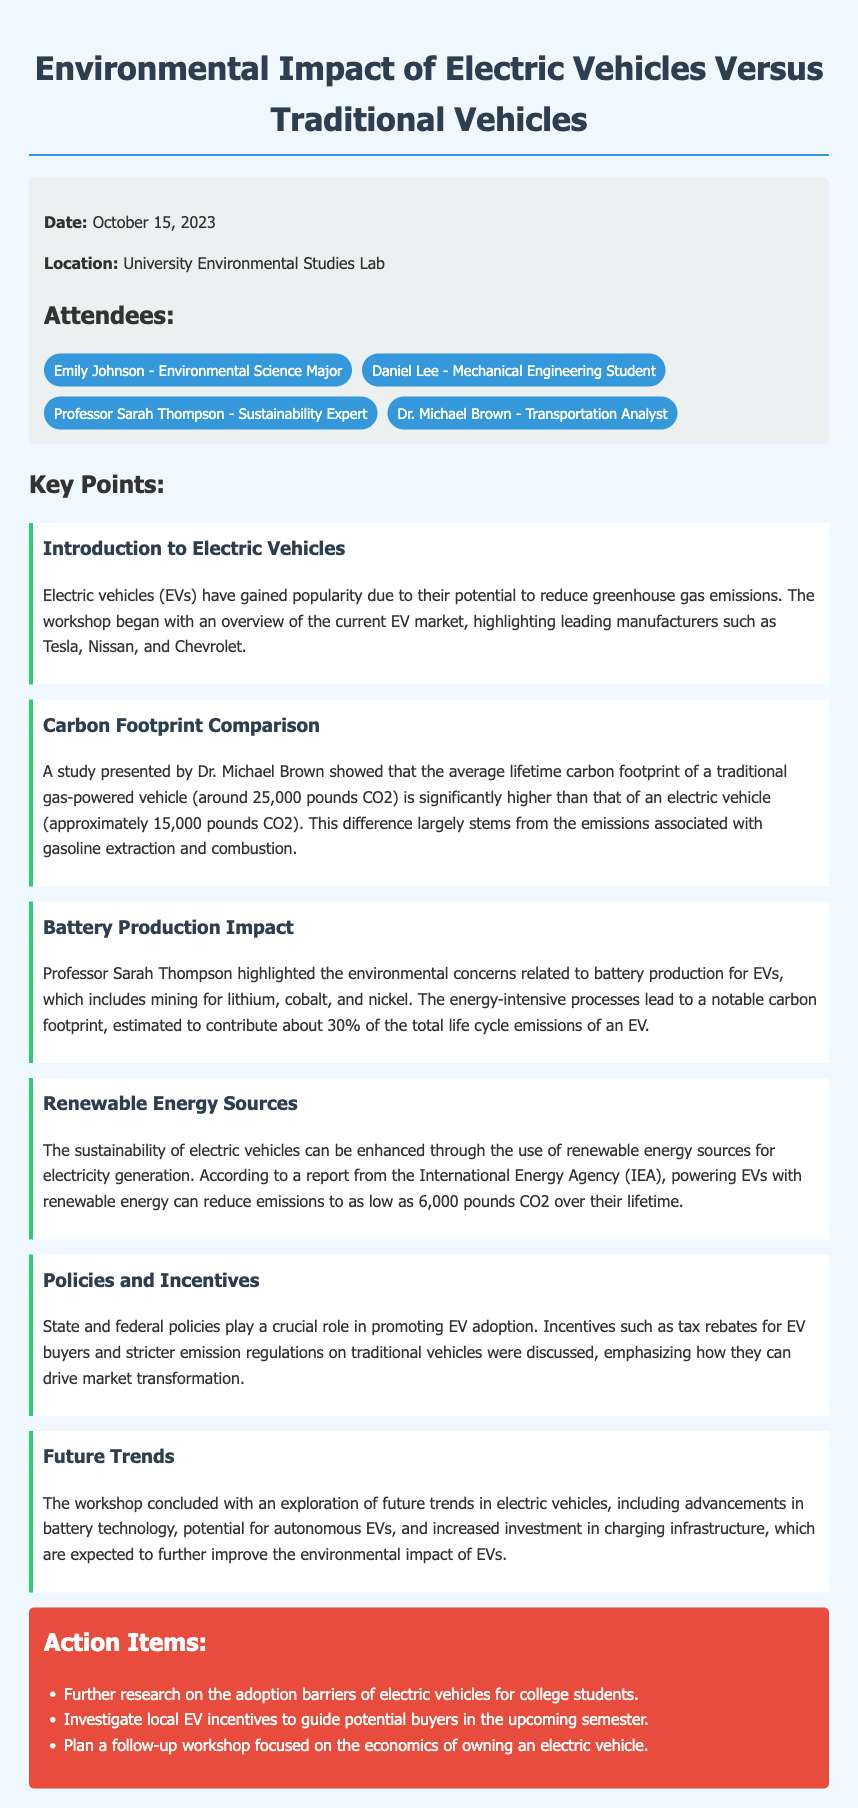what was the date of the workshop? The date is specified in the info box of the document.
Answer: October 15, 2023 who presented the carbon footprint comparison? The presenter of this comparison is mentioned within the key points of the document.
Answer: Dr. Michael Brown what is the estimated lifetime carbon footprint of an electric vehicle? The document provides a specific figure regarding the carbon footprint of electric vehicles in the carbon footprint comparison section.
Answer: approximately 15,000 pounds CO2 what percentage of EVs' total life cycle emissions is contributed by battery production? The document specifies a percentage related to battery production's impact in the key points section.
Answer: about 30% which energy source can help reduce EV emissions to as low as 6,000 pounds CO2? The document indicates the energy source that can achieve this reduction in the section about renewable energy sources.
Answer: renewable energy what are the two types of policies discussed that promote EV adoption? The document mentions specific types of policies in the policies and incentives section.
Answer: tax rebates and emission regulations which manufacturer was NOT mentioned as a leading EV manufacturer? The leading manufacturers are explicitly listed in the introduction to electric vehicles section.
Answer: None (every mentioned manufacturer is a leading one) what is the main focus of the next planned workshop? The action items section states the topic of the follow-up workshop.
Answer: economics of owning an electric vehicle 